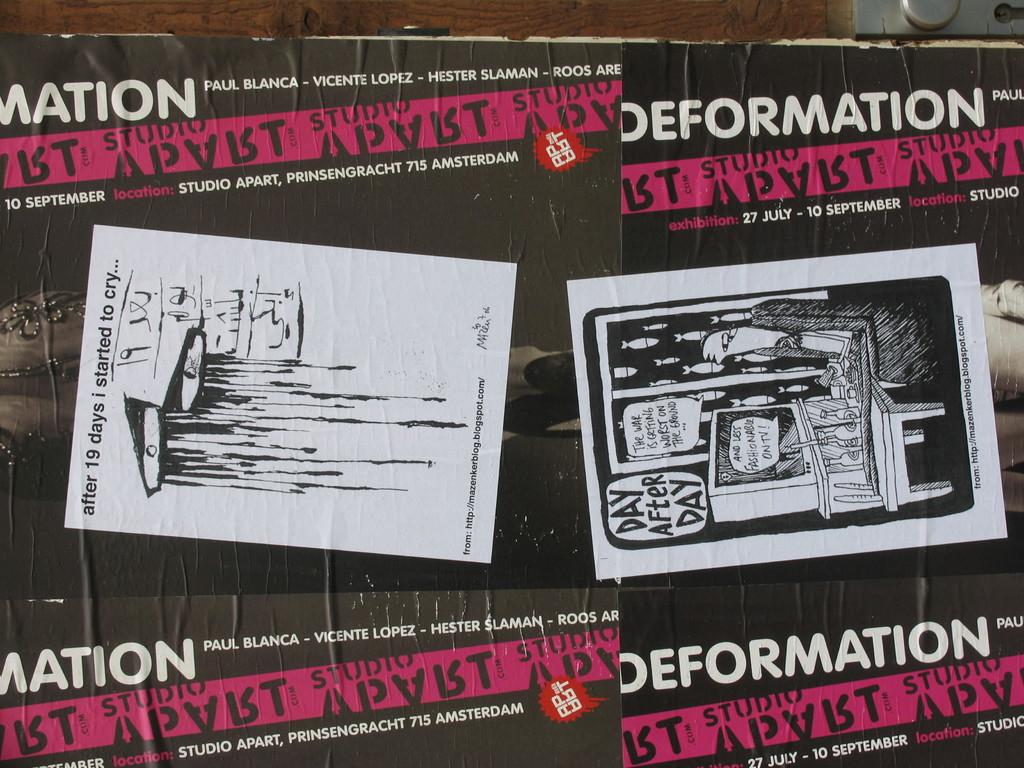What is on the wall in the image? There is a poster on the wall in the image. What can be found in the top right corner of the image? There is a steel box in the top right corner of the image. What is depicted on the poster? The poster contains images or representations of a television, a table, quotations, and an address. What type of jeans is the person wearing in the image? There is no person visible in the image, so it is not possible to determine what type of jeans they might be wearing. What color are the shoes worn by the person in the image? There is no person visible in the image, so it is not possible to determine the color of any shoes they might be wearing. 